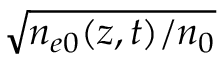<formula> <loc_0><loc_0><loc_500><loc_500>\sqrt { n _ { e 0 } ( z , t ) / n _ { 0 } }</formula> 